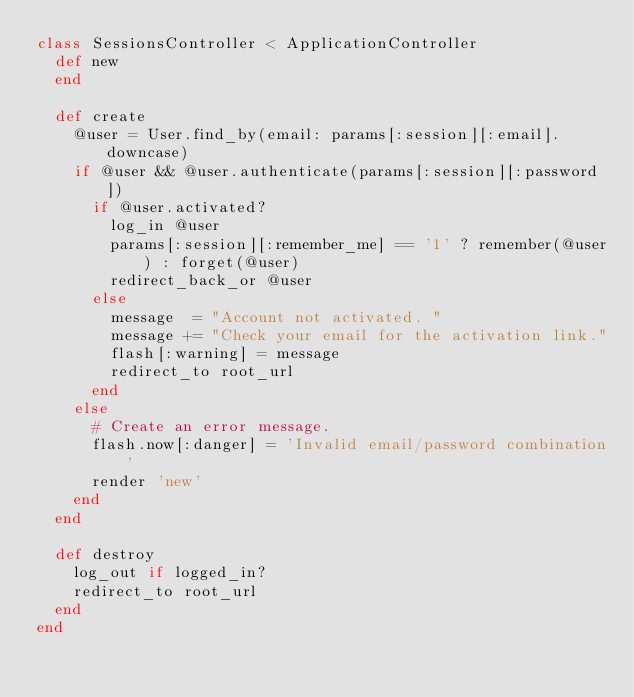<code> <loc_0><loc_0><loc_500><loc_500><_Ruby_>class SessionsController < ApplicationController
  def new
  end

  def create
    @user = User.find_by(email: params[:session][:email].downcase)
    if @user && @user.authenticate(params[:session][:password])
      if @user.activated?
        log_in @user
        params[:session][:remember_me] == '1' ? remember(@user) : forget(@user)
        redirect_back_or @user
      else
        message  = "Account not activated. "
        message += "Check your email for the activation link."
        flash[:warning] = message
        redirect_to root_url
      end
    else
      # Create an error message.
      flash.now[:danger] = 'Invalid email/password combination'
      render 'new'
    end
  end

  def destroy
    log_out if logged_in?
    redirect_to root_url
  end
end
</code> 